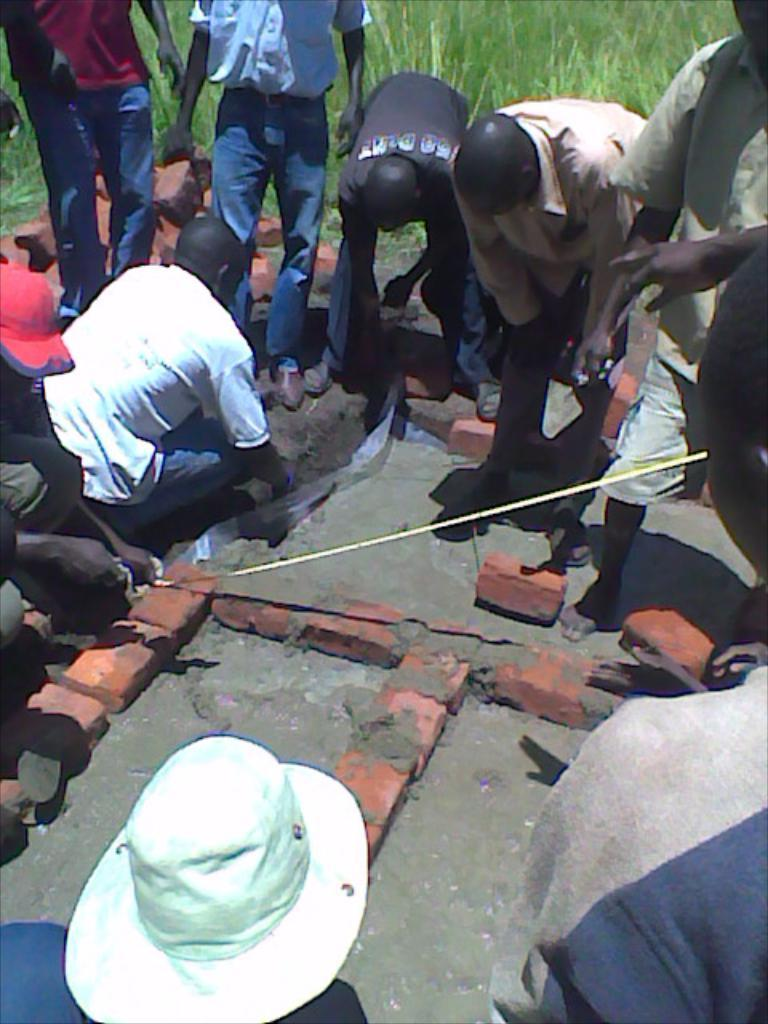What is the main subject of the image? The main subject of the image is the persons standing in the middle and at the bottom of the image. Can you describe the location of the persons in the image? Yes, there are persons standing in the middle and at the bottom of the image. What type of vegetation is visible in the image? Grass is visible at the top of the image. What type of juice is being served by the mother in the image? There is no mother or juice present in the image. 